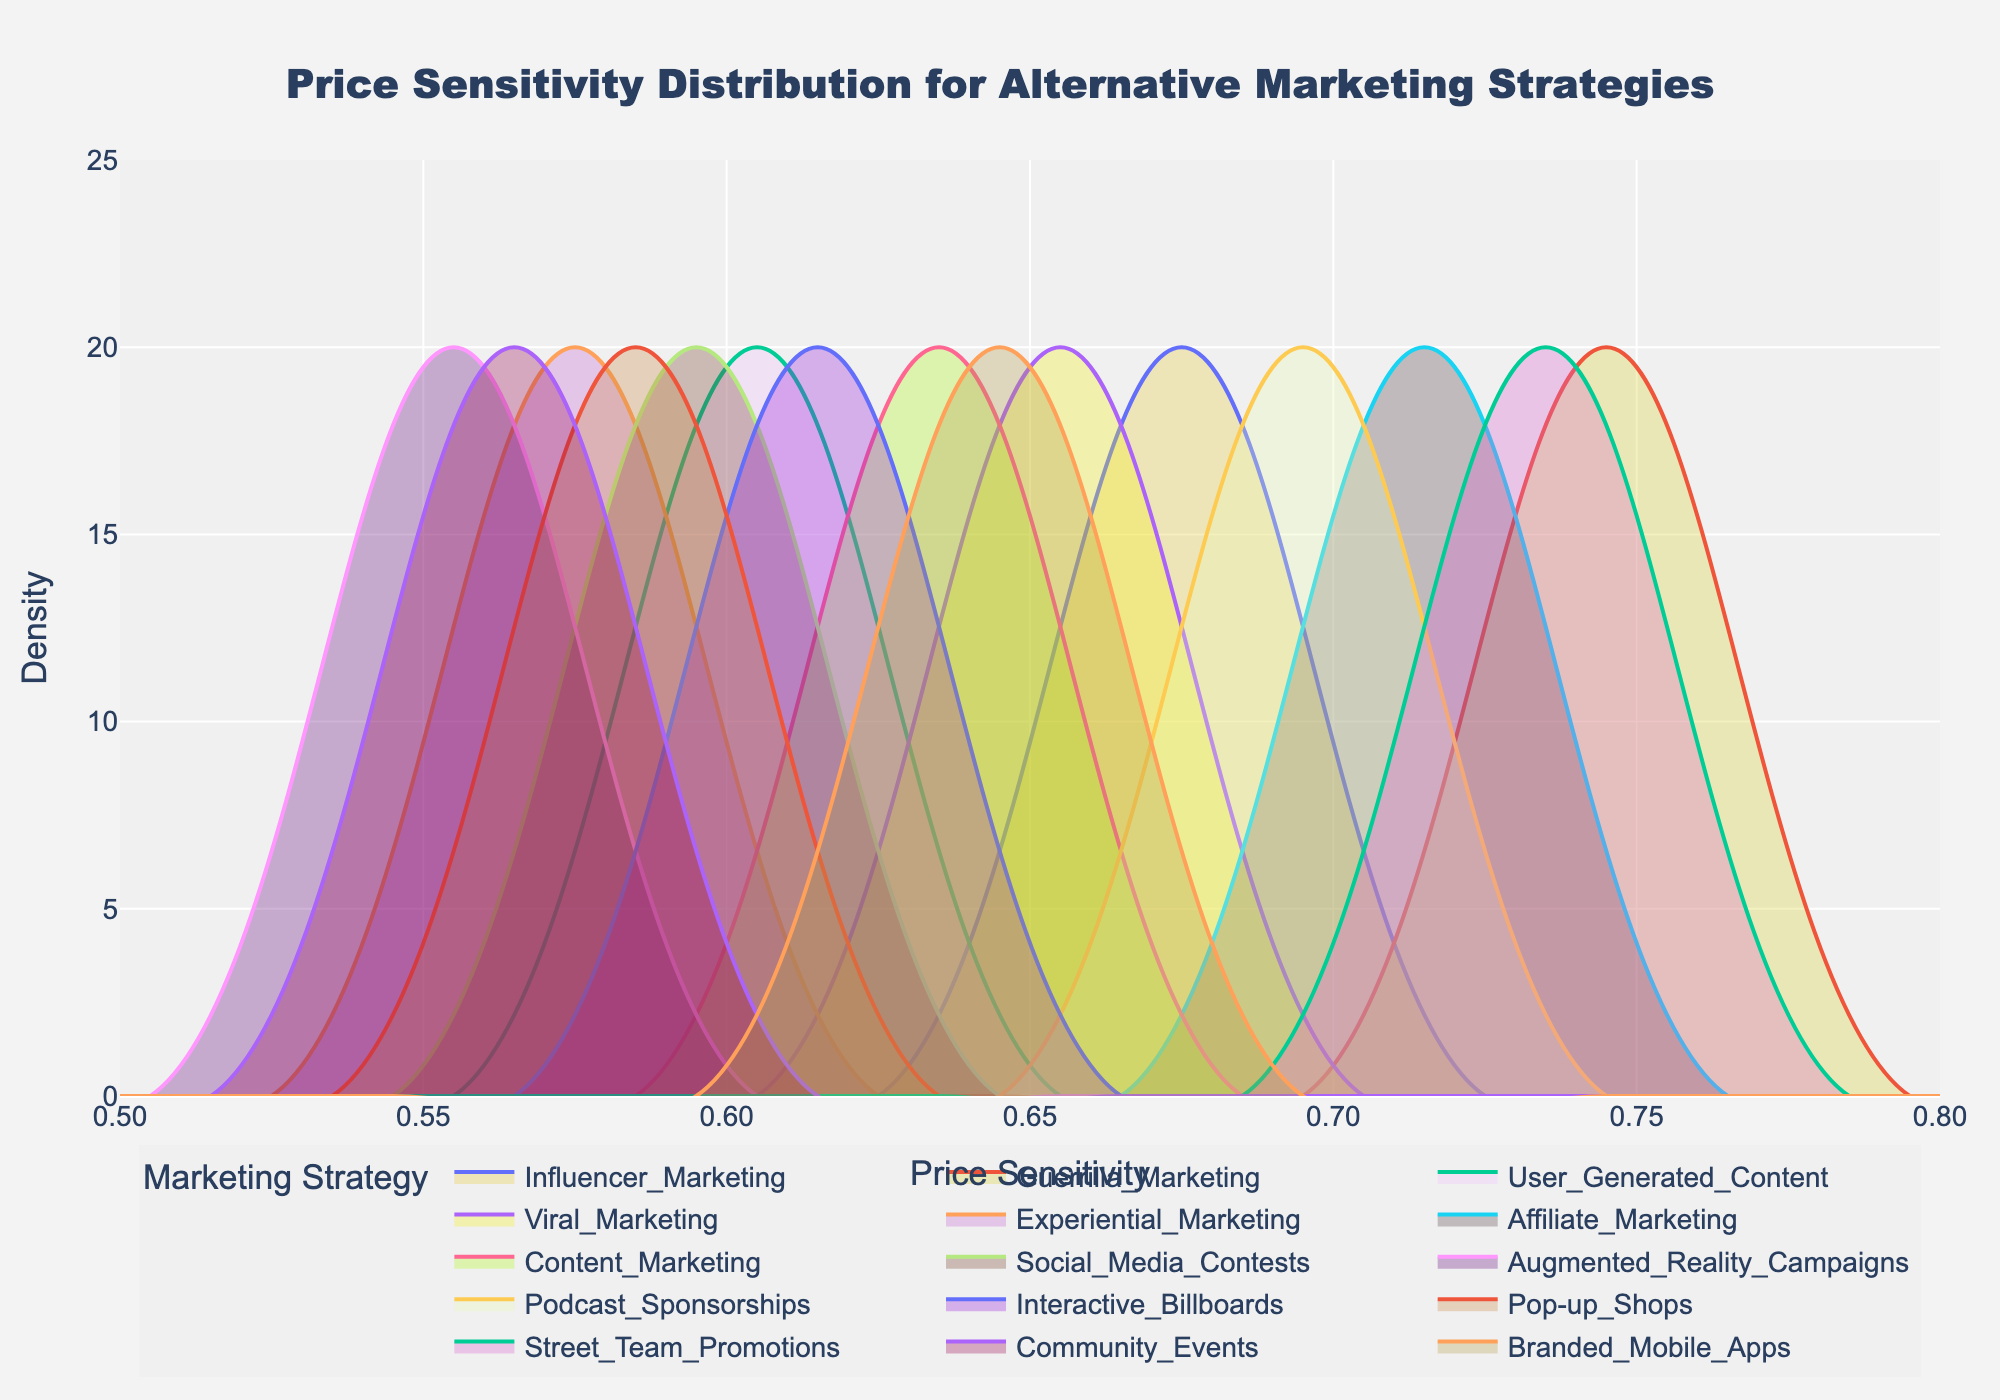what is the title of the figure? The title is located at the top center of the figure.
Answer: Price Sensitivity Distribution for Alternative Marketing Strategies what is the x-axis labeled? The label is provided directly below the horizontal axis of the figure.
Answer: Price Sensitivity which strategy has the highest peak density on the plot? By looking at the tallest peak among the density plots for all strategies, we can identify the one with the highest peak.
Answer: Guerrilla Marketing which strategy has the lowest range of price sensitivity? The range can be identified by looking at the width of the density plot for each strategy; the narrower the plot, the smaller the range.
Answer: Augmented Reality Campaigns how many different marketing strategies are compared in the plot? Count the unique labeled density plots in the figure.
Answer: 15 which strategy has a price sensitivity peak around 0.55? Identify the density plot with the highest peak near the price sensitivity value of 0.55.
Answer: Experiential Marketing which strategy shows a peak density value near 25? Locate the density plot with a peak that is closest to the vertical axis value of 25.
Answer: Guerrilla Marketing is any strategy's density plot completely above a price sensitivity of 0.6? Check all density plots to see if any one of them starts and ends above the price sensitivity value of 0.6.
Answer: No which two strategies have the closest peak price sensitivity values? Compare the peak positions of each density plot to find the two strategies with peaks that are closest to each other.
Answer: Influencer Marketing and Viral Marketing based on the figure, which strategy would you consider having the highest price sensitivity? Identify the strategy with the highest peak position and the largest density value.
Answer: Guerrilla Marketing 